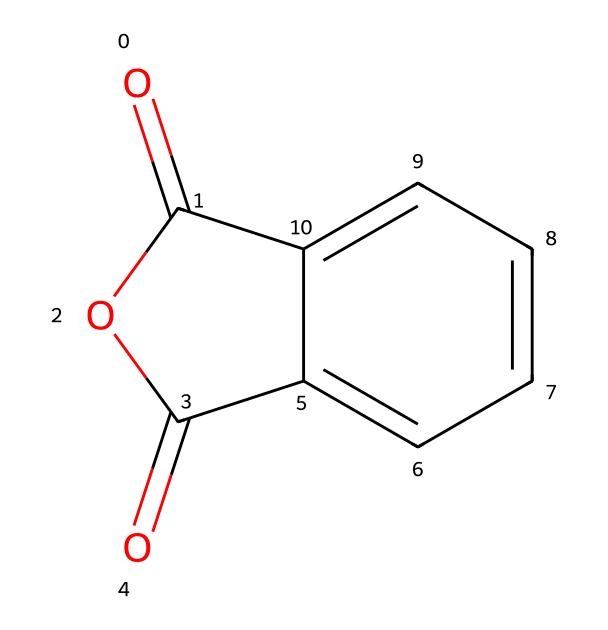What is the molecular formula of phthalic anhydride? The SMILES representation indicates the number of carbon, hydrogen, and oxygen atoms. The structure shows 8 carbon atoms, 4 hydrogen atoms, and 3 oxygen atoms. Thus, the molecular formula is C8H4O3.
Answer: C8H4O3 How many rings are present in the structure of phthalic anhydride? The structure includes a cyclic compound where two carbonyl groups are incorporated in a five-membered ring. This indicates there is one ring present in the structure.
Answer: 1 What functional groups are present in phthalic anhydride? Analyzing the structure, we can identify carbonyl (C=O) groups and an anhydride functional group, attributed to the connections between carbonyls T his indicates that both functional groups are present.
Answer: carbonyl and anhydride How many double bonds are present in phthalic anhydride? Examining the chemical structure, we observe that there are two carbon-to-oxygen double bonds (C=O) in the molecule, resulting in a total of two double bonds.
Answer: 2 What type of chemical is phthalic anhydride classified as? Due to its structure characterized by an anhydride formation involving a cyclic structure and carbonyl groups, phthalic anhydride is classified as an acid anhydride.
Answer: acid anhydride Why is phthalic anhydride used in perfume fixatives? The presence of multiple carbonyl groups and its stable cyclic structure allow for strong intermolecular interactions, making it effective in prolonging perfume scent.
Answer: strong intermolecular interactions 